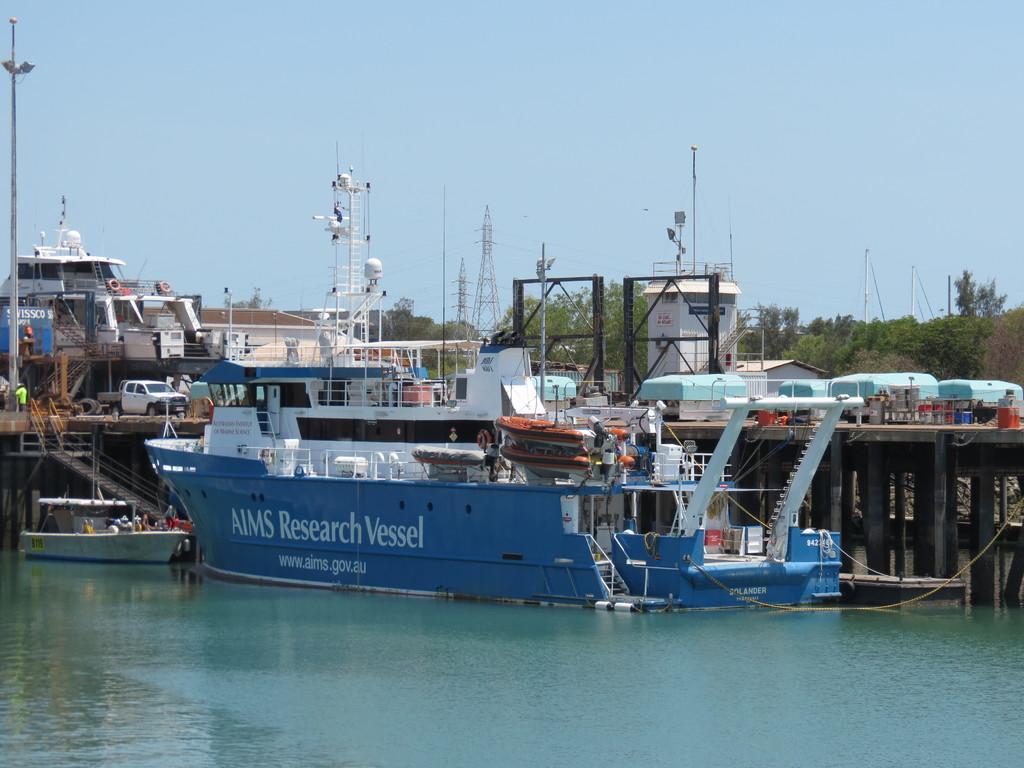Can you describe this image briefly? In the center of the image we can see ship on the water. In the background we can see pillars, bridge, containers, ships, vehicle, boat, trees, towers and sky. 